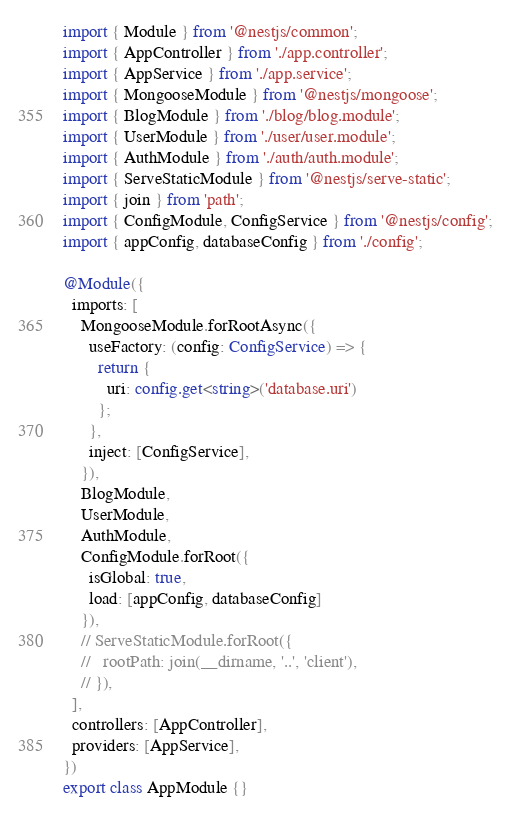<code> <loc_0><loc_0><loc_500><loc_500><_TypeScript_>import { Module } from '@nestjs/common';
import { AppController } from './app.controller';
import { AppService } from './app.service';
import { MongooseModule } from '@nestjs/mongoose';
import { BlogModule } from './blog/blog.module';
import { UserModule } from './user/user.module';
import { AuthModule } from './auth/auth.module';
import { ServeStaticModule } from '@nestjs/serve-static';
import { join } from 'path';
import { ConfigModule, ConfigService } from '@nestjs/config';
import { appConfig, databaseConfig } from './config';

@Module({
  imports: [
    MongooseModule.forRootAsync({
      useFactory: (config: ConfigService) => {
        return {
          uri: config.get<string>('database.uri')
        };
      },
      inject: [ConfigService],
    }),
    BlogModule,
    UserModule,
    AuthModule,
    ConfigModule.forRoot({
      isGlobal: true,
      load: [appConfig, databaseConfig]
    }),
    // ServeStaticModule.forRoot({
    //   rootPath: join(__dirname, '..', 'client'),
    // }),
  ],
  controllers: [AppController],
  providers: [AppService],
})
export class AppModule {}
</code> 